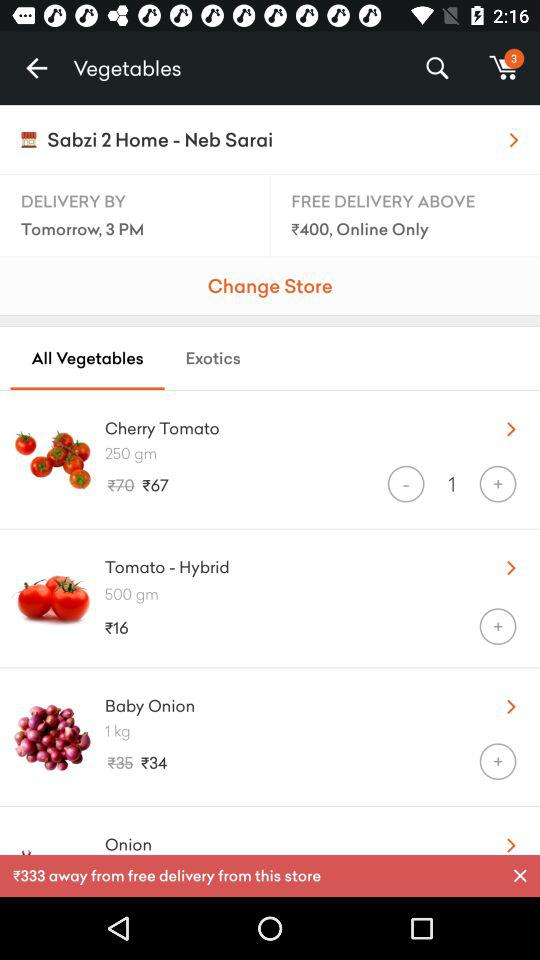Which are the different vegetables? The different vegetables are "Cherry Tomato", "Tomato - Hybrid", "Baby Onion" and "Onion". 